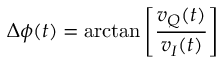<formula> <loc_0><loc_0><loc_500><loc_500>\Delta \phi ( t ) = \arctan \left [ \frac { v _ { Q } ( t ) } { v _ { I } ( t ) } \right ]</formula> 